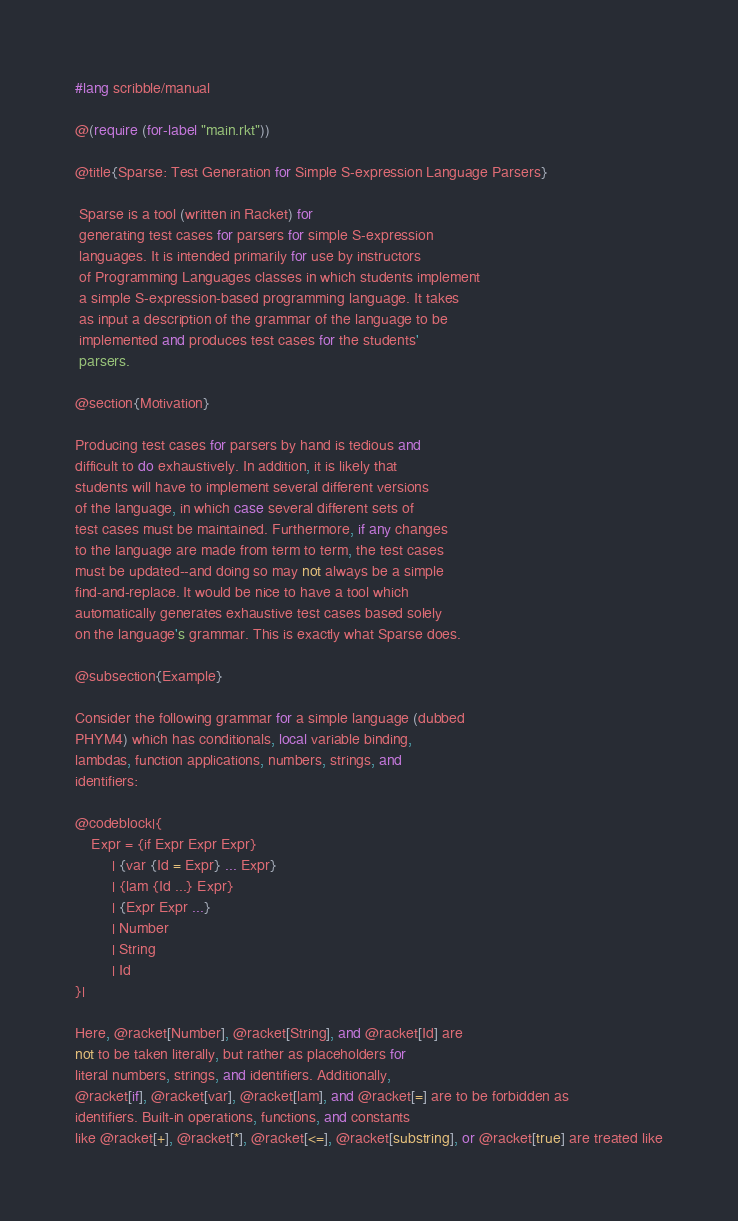Convert code to text. <code><loc_0><loc_0><loc_500><loc_500><_Racket_>#lang scribble/manual

@(require (for-label "main.rkt"))

@title{Sparse: Test Generation for Simple S-expression Language Parsers}

 Sparse is a tool (written in Racket) for
 generating test cases for parsers for simple S-expression
 languages. It is intended primarily for use by instructors
 of Programming Languages classes in which students implement
 a simple S-expression-based programming language. It takes
 as input a description of the grammar of the language to be
 implemented and produces test cases for the students'
 parsers.

@section{Motivation}

Producing test cases for parsers by hand is tedious and
difficult to do exhaustively. In addition, it is likely that
students will have to implement several different versions
of the language, in which case several different sets of
test cases must be maintained. Furthermore, if any changes
to the language are made from term to term, the test cases
must be updated--and doing so may not always be a simple
find-and-replace. It would be nice to have a tool which
automatically generates exhaustive test cases based solely
on the language's grammar. This is exactly what Sparse does.

@subsection{Example}

Consider the following grammar for a simple language (dubbed
PHYM4) which has conditionals, local variable binding,
lambdas, function applications, numbers, strings, and
identifiers:

@codeblock|{
    Expr = {if Expr Expr Expr}
         | {var {Id = Expr} ... Expr}
         | {lam {Id ...} Expr}
         | {Expr Expr ...}
         | Number
         | String
         | Id
}|

Here, @racket[Number], @racket[String], and @racket[Id] are
not to be taken literally, but rather as placeholders for
literal numbers, strings, and identifiers. Additionally,
@racket[if], @racket[var], @racket[lam], and @racket[=] are to be forbidden as
identifiers. Built-in operations, functions, and constants
like @racket[+], @racket[*], @racket[<=], @racket[substring], or @racket[true] are treated like</code> 